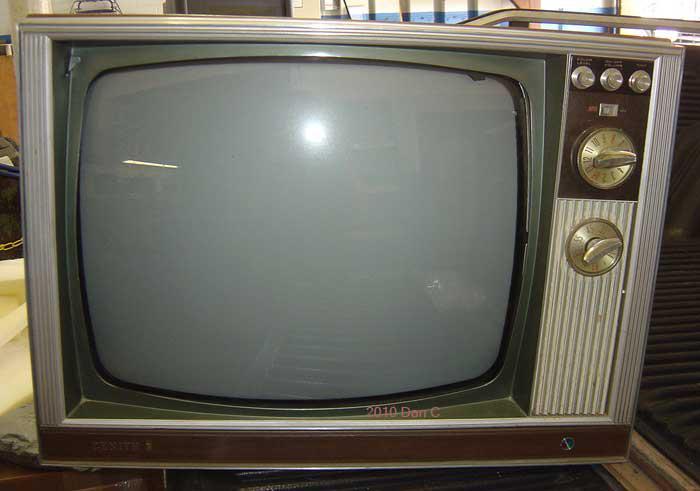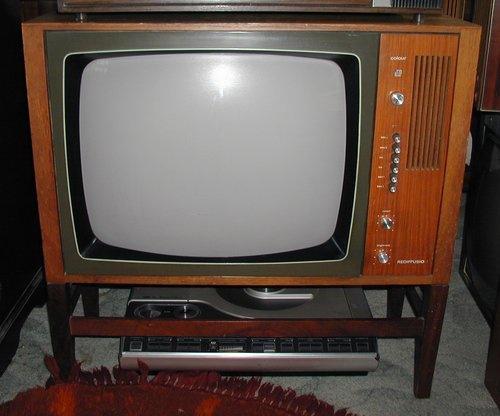The first image is the image on the left, the second image is the image on the right. Assess this claim about the two images: "Two televisions are shown, one a tabletop model, and the other in a wooden console cabinet on legs.". Correct or not? Answer yes or no. Yes. 